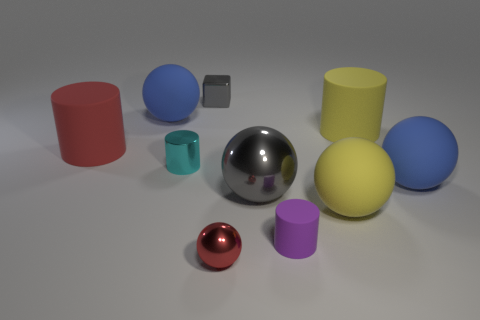Subtract all large yellow rubber cylinders. How many cylinders are left? 3 Subtract all yellow spheres. How many spheres are left? 4 Subtract 5 balls. How many balls are left? 0 Subtract all cylinders. How many objects are left? 6 Subtract all red cylinders. How many cyan spheres are left? 0 Subtract all large metallic spheres. Subtract all red rubber cylinders. How many objects are left? 8 Add 4 large blue things. How many large blue things are left? 6 Add 8 brown metallic things. How many brown metallic things exist? 8 Subtract 0 cyan balls. How many objects are left? 10 Subtract all blue balls. Subtract all green cubes. How many balls are left? 3 